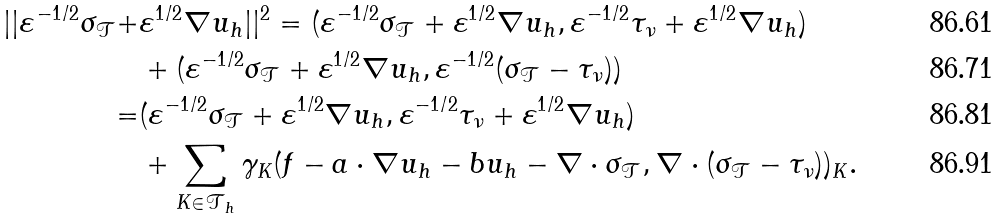Convert formula to latex. <formula><loc_0><loc_0><loc_500><loc_500>| | \varepsilon ^ { - 1 / 2 } \sigma _ { \mathcal { T } } + & \varepsilon ^ { 1 / 2 } \nabla u _ { h } | | ^ { 2 } = ( \varepsilon ^ { - 1 / 2 } \sigma _ { \mathcal { T } } + \varepsilon ^ { 1 / 2 } \nabla u _ { h } , \varepsilon ^ { - 1 / 2 } \tau _ { \nu } + \varepsilon ^ { 1 / 2 } \nabla u _ { h } ) \\ & + ( \varepsilon ^ { - 1 / 2 } \sigma _ { \mathcal { T } } + \varepsilon ^ { 1 / 2 } \nabla u _ { h } , \varepsilon ^ { - 1 / 2 } ( \sigma _ { \mathcal { T } } - \tau _ { \nu } ) ) \\ = & ( \varepsilon ^ { - 1 / 2 } \sigma _ { \mathcal { T } } + \varepsilon ^ { 1 / 2 } \nabla u _ { h } , \varepsilon ^ { - 1 / 2 } \tau _ { \nu } + \varepsilon ^ { 1 / 2 } \nabla u _ { h } ) \\ & + \sum _ { K \in \mathcal { T } _ { h } } \gamma _ { K } ( f - { a } \cdot \nabla u _ { h } - b u _ { h } - \nabla \cdot \sigma _ { \mathcal { T } } , \nabla \cdot ( \sigma _ { \mathcal { T } } - \tau _ { \nu } ) ) _ { K } .</formula> 